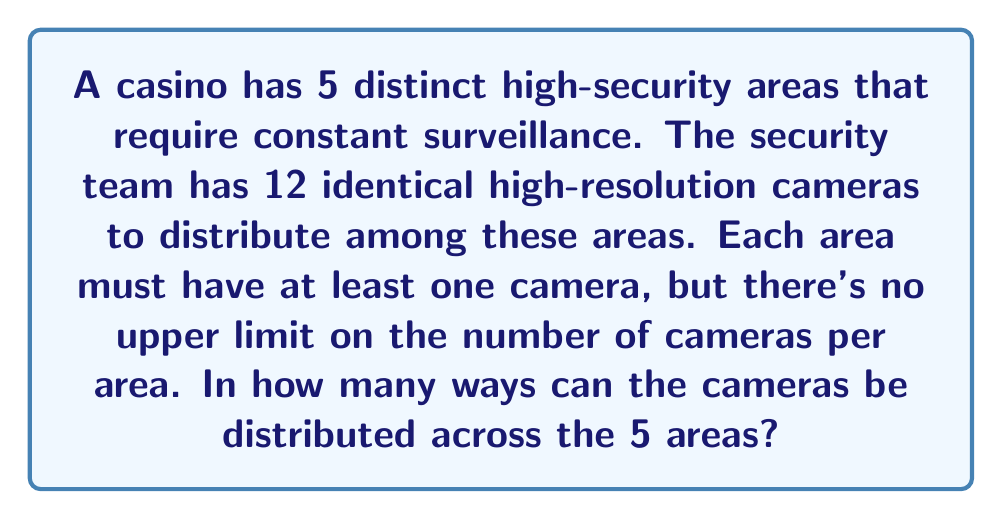Give your solution to this math problem. To solve this problem, we can use the concept of stars and bars (also known as balls and urns) from combinatorics.

1) We have 12 cameras (stars) to distribute among 5 areas (bars).

2) Each area must have at least one camera. To ensure this, we can first allocate one camera to each area. This leaves us with 7 cameras (12 - 5 = 7) to distribute freely.

3) Now, we need to find the number of ways to distribute 7 identical objects (remaining cameras) into 5 distinct groups (areas).

4) This scenario is equivalent to placing 7 stars in a line and choosing 4 positions to place bars, which will create 5 groups.

5) The total number of objects we're arranging is 7 stars + 4 bars = 11 objects.

6) We need to choose 4 positions out of these 11 for the bars (or equivalently, 7 positions for the stars).

7) This is a combination problem. The number of ways to choose 4 positions out of 11 is given by the combination formula:

   $$\binom{11}{4} = \frac{11!}{4!(11-4)!} = \frac{11!}{4!7!}$$

8) Calculating this:
   $$\frac{11 * 10 * 9 * 8 * 7!}{(4 * 3 * 2 * 1) * 7!} = \frac{7920}{24} = 330$$

Therefore, there are 330 ways to distribute the cameras.
Answer: 330 